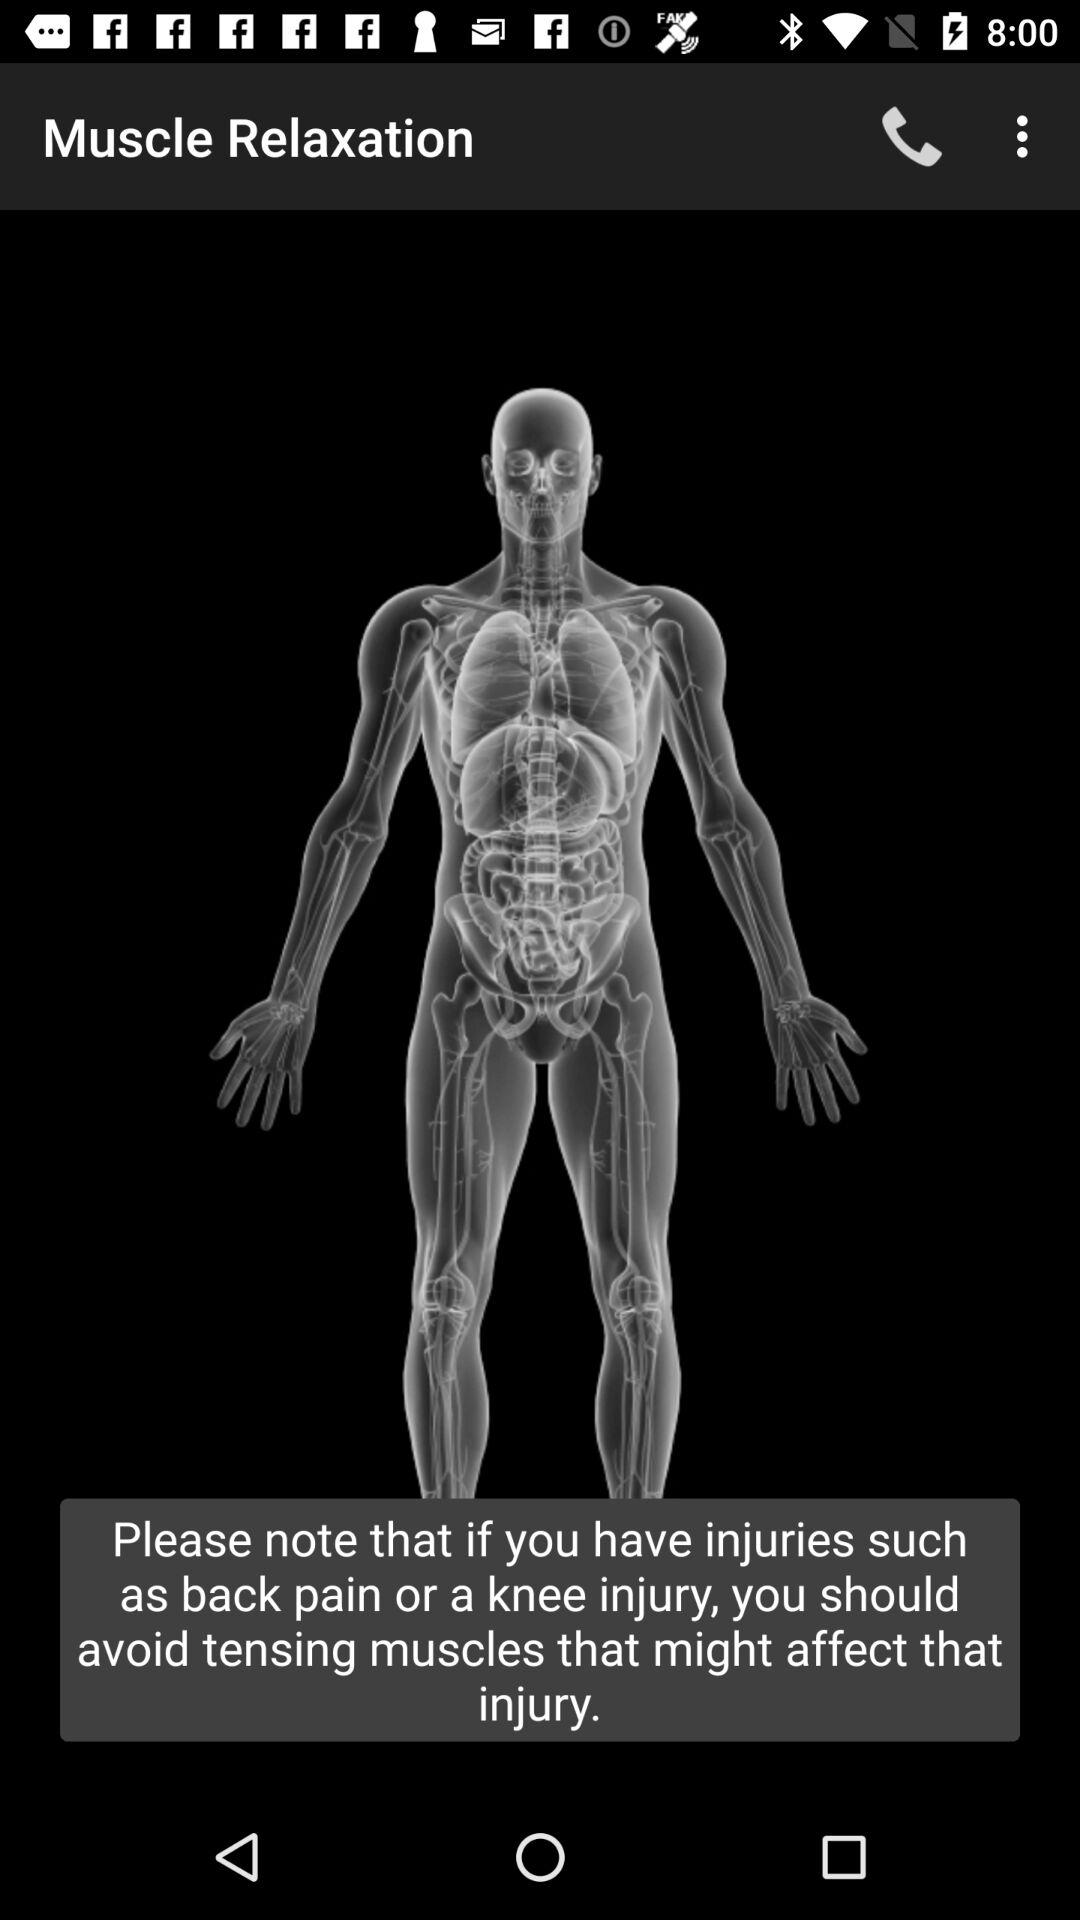What is the contact number of the application?
When the provided information is insufficient, respond with <no answer>. <no answer> 